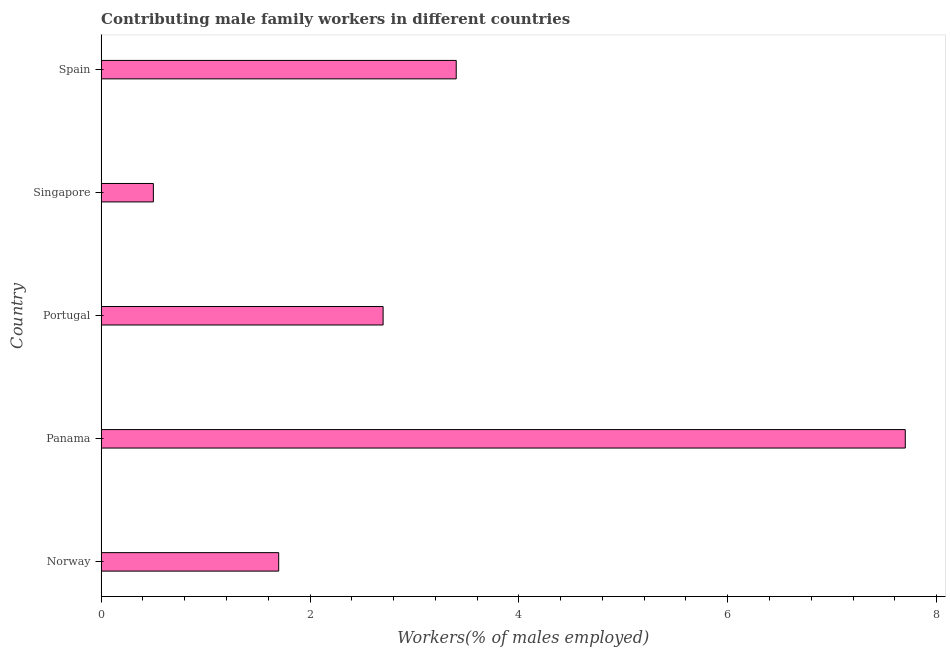Does the graph contain grids?
Make the answer very short. No. What is the title of the graph?
Your response must be concise. Contributing male family workers in different countries. What is the label or title of the X-axis?
Keep it short and to the point. Workers(% of males employed). Across all countries, what is the maximum contributing male family workers?
Provide a short and direct response. 7.7. Across all countries, what is the minimum contributing male family workers?
Provide a succinct answer. 0.5. In which country was the contributing male family workers maximum?
Make the answer very short. Panama. In which country was the contributing male family workers minimum?
Offer a very short reply. Singapore. What is the sum of the contributing male family workers?
Ensure brevity in your answer.  16. What is the average contributing male family workers per country?
Keep it short and to the point. 3.2. What is the median contributing male family workers?
Make the answer very short. 2.7. In how many countries, is the contributing male family workers greater than 1.2 %?
Keep it short and to the point. 4. What is the ratio of the contributing male family workers in Portugal to that in Singapore?
Offer a very short reply. 5.4. What is the difference between the highest and the second highest contributing male family workers?
Keep it short and to the point. 4.3. Is the sum of the contributing male family workers in Panama and Spain greater than the maximum contributing male family workers across all countries?
Offer a very short reply. Yes. What is the difference between the highest and the lowest contributing male family workers?
Give a very brief answer. 7.2. Are all the bars in the graph horizontal?
Your answer should be very brief. Yes. What is the difference between two consecutive major ticks on the X-axis?
Offer a terse response. 2. Are the values on the major ticks of X-axis written in scientific E-notation?
Your answer should be compact. No. What is the Workers(% of males employed) of Norway?
Provide a succinct answer. 1.7. What is the Workers(% of males employed) of Panama?
Provide a succinct answer. 7.7. What is the Workers(% of males employed) in Portugal?
Give a very brief answer. 2.7. What is the Workers(% of males employed) of Singapore?
Keep it short and to the point. 0.5. What is the Workers(% of males employed) in Spain?
Provide a succinct answer. 3.4. What is the difference between the Workers(% of males employed) in Norway and Singapore?
Your answer should be very brief. 1.2. What is the difference between the Workers(% of males employed) in Norway and Spain?
Give a very brief answer. -1.7. What is the difference between the Workers(% of males employed) in Panama and Spain?
Make the answer very short. 4.3. What is the difference between the Workers(% of males employed) in Portugal and Singapore?
Provide a short and direct response. 2.2. What is the ratio of the Workers(% of males employed) in Norway to that in Panama?
Make the answer very short. 0.22. What is the ratio of the Workers(% of males employed) in Norway to that in Portugal?
Make the answer very short. 0.63. What is the ratio of the Workers(% of males employed) in Norway to that in Singapore?
Make the answer very short. 3.4. What is the ratio of the Workers(% of males employed) in Norway to that in Spain?
Provide a short and direct response. 0.5. What is the ratio of the Workers(% of males employed) in Panama to that in Portugal?
Your answer should be compact. 2.85. What is the ratio of the Workers(% of males employed) in Panama to that in Singapore?
Keep it short and to the point. 15.4. What is the ratio of the Workers(% of males employed) in Panama to that in Spain?
Provide a succinct answer. 2.27. What is the ratio of the Workers(% of males employed) in Portugal to that in Spain?
Keep it short and to the point. 0.79. What is the ratio of the Workers(% of males employed) in Singapore to that in Spain?
Keep it short and to the point. 0.15. 